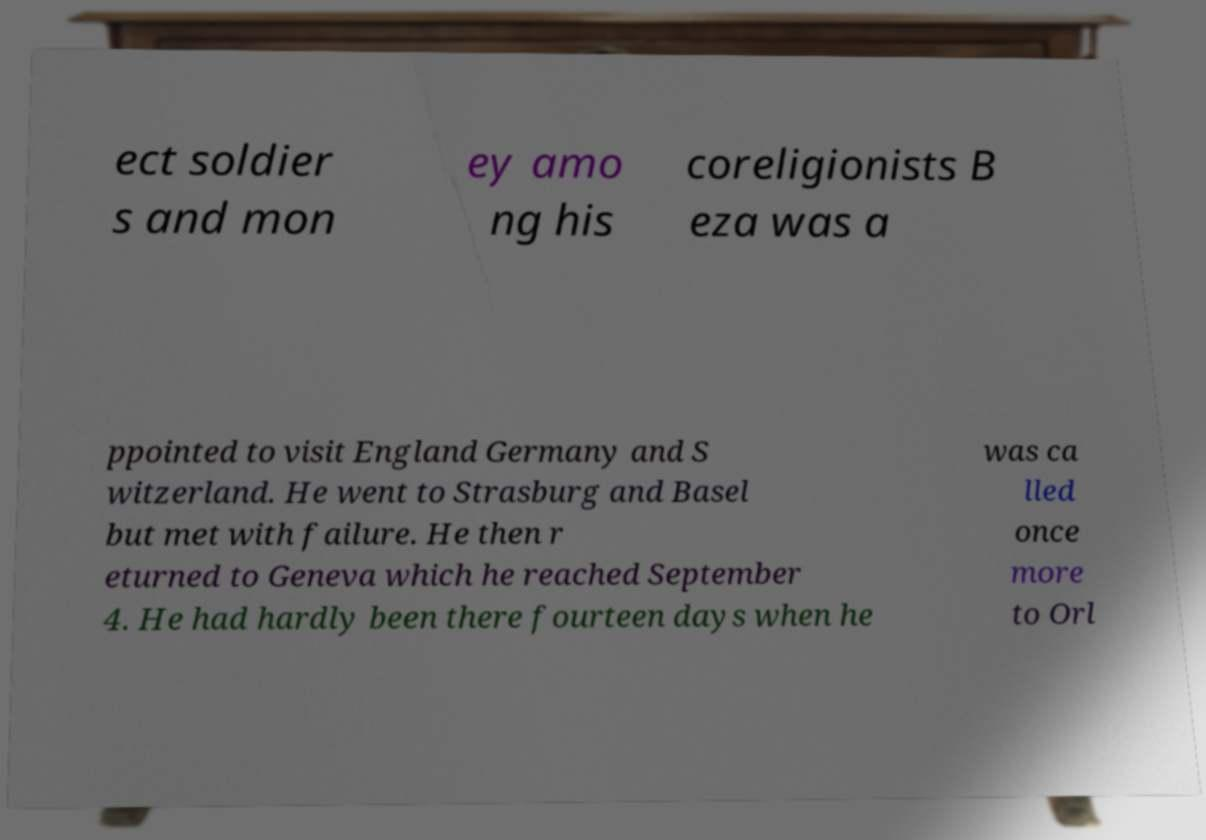There's text embedded in this image that I need extracted. Can you transcribe it verbatim? ect soldier s and mon ey amo ng his coreligionists B eza was a ppointed to visit England Germany and S witzerland. He went to Strasburg and Basel but met with failure. He then r eturned to Geneva which he reached September 4. He had hardly been there fourteen days when he was ca lled once more to Orl 